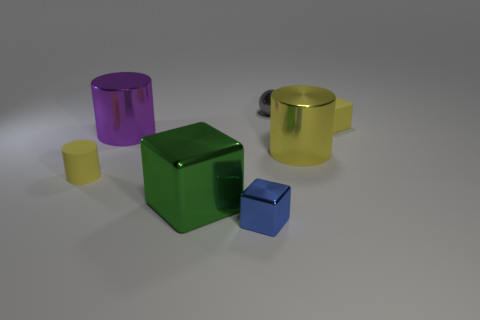Subtract 1 cylinders. How many cylinders are left? 2 Subtract all cylinders. How many objects are left? 4 Add 1 metallic balls. How many objects exist? 8 Subtract 0 cyan cylinders. How many objects are left? 7 Subtract all yellow objects. Subtract all big blue shiny cylinders. How many objects are left? 4 Add 4 large green objects. How many large green objects are left? 5 Add 5 small green matte cylinders. How many small green matte cylinders exist? 5 